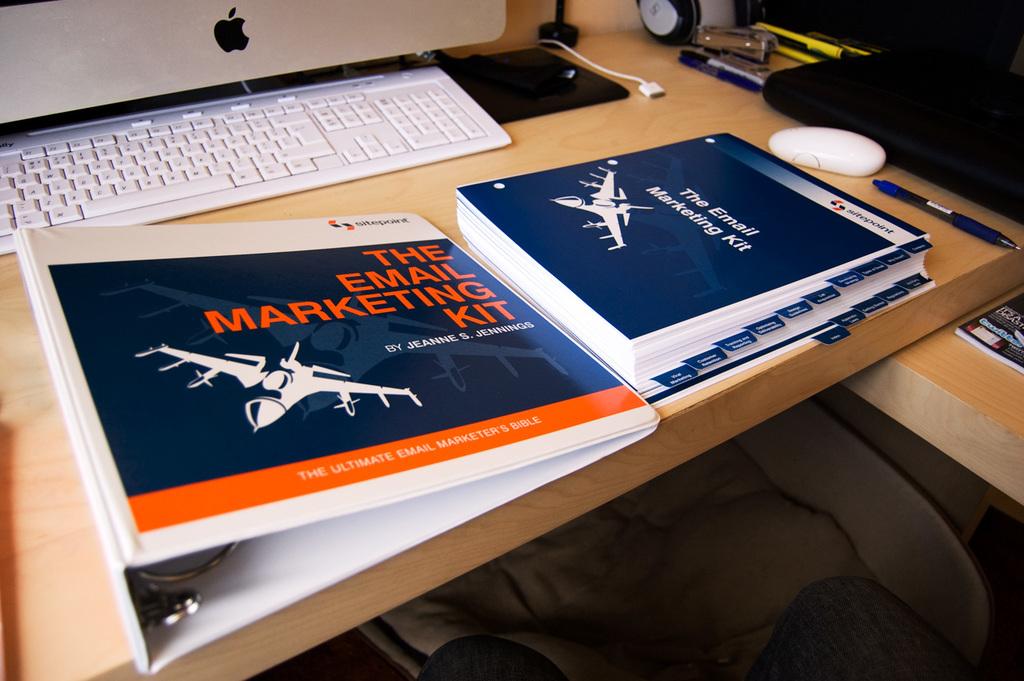What kind of kit is displayed here?
Your answer should be compact. Email marketing. What does the book say?
Your response must be concise. The email marketing kit. 